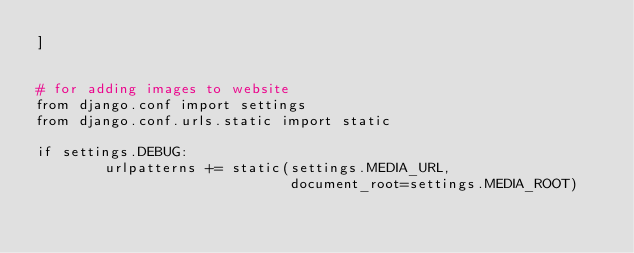Convert code to text. <code><loc_0><loc_0><loc_500><loc_500><_Python_>]


# for adding images to website
from django.conf import settings
from django.conf.urls.static import static

if settings.DEBUG:
        urlpatterns += static(settings.MEDIA_URL,
                              document_root=settings.MEDIA_ROOT)</code> 